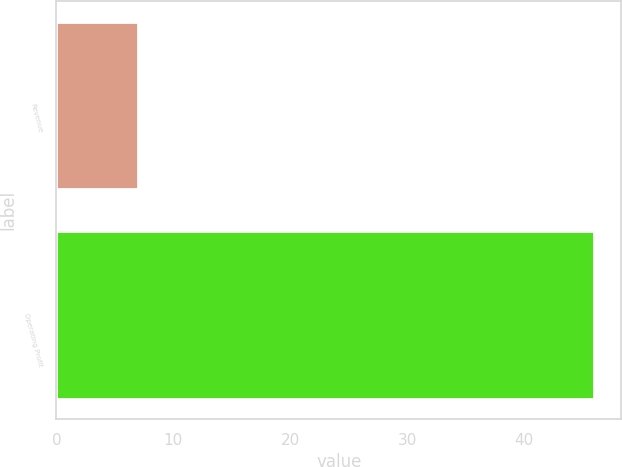Convert chart. <chart><loc_0><loc_0><loc_500><loc_500><bar_chart><fcel>Revenue<fcel>Operating Profit<nl><fcel>7<fcel>46<nl></chart> 